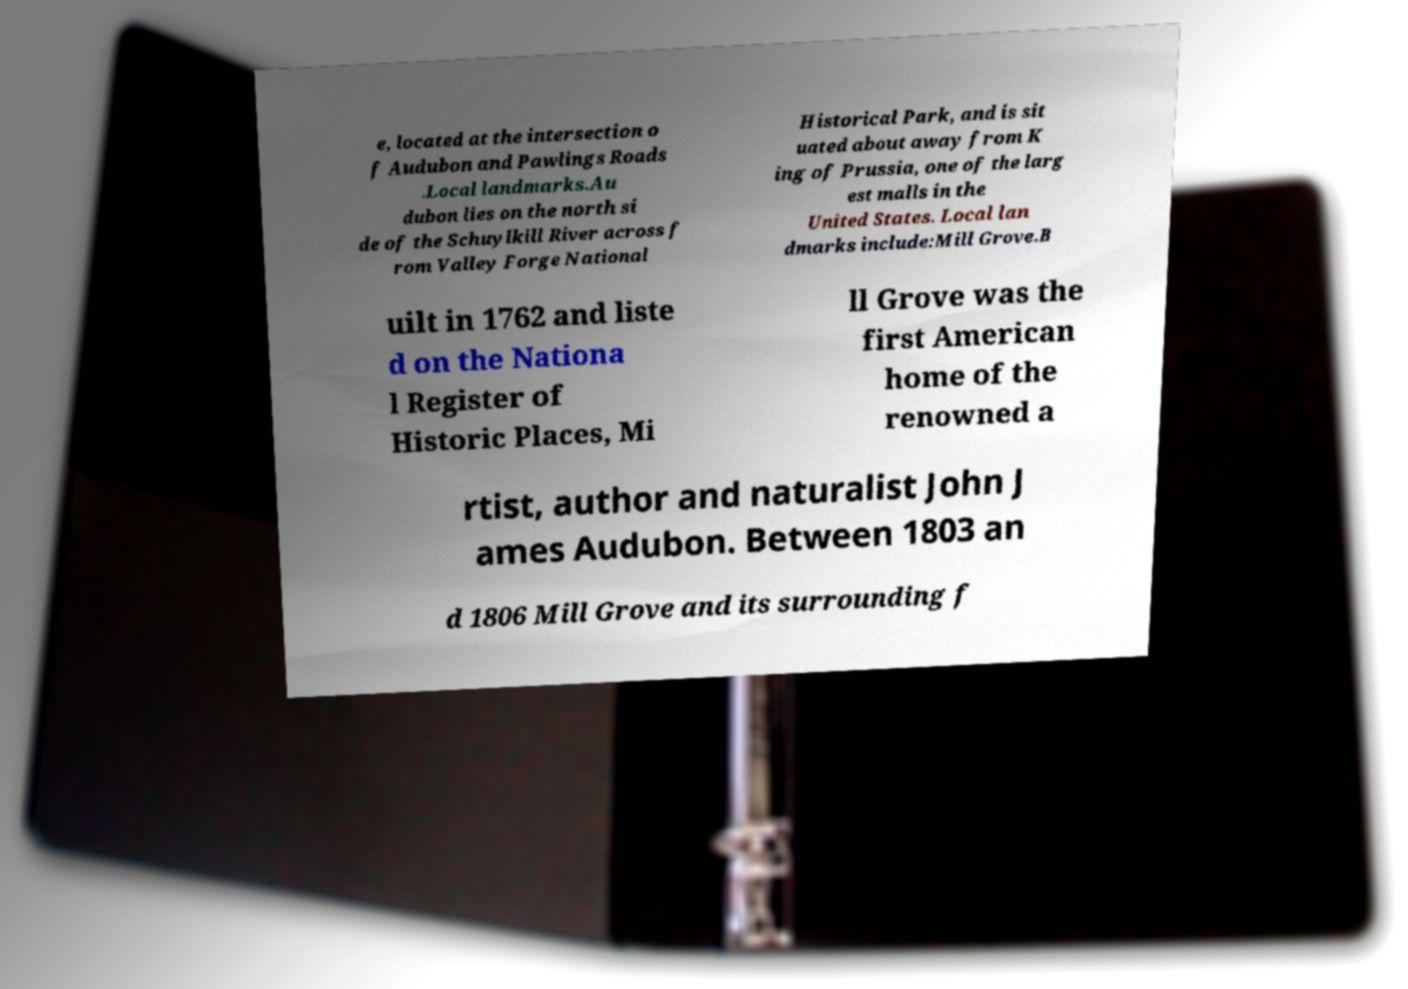Could you assist in decoding the text presented in this image and type it out clearly? e, located at the intersection o f Audubon and Pawlings Roads .Local landmarks.Au dubon lies on the north si de of the Schuylkill River across f rom Valley Forge National Historical Park, and is sit uated about away from K ing of Prussia, one of the larg est malls in the United States. Local lan dmarks include:Mill Grove.B uilt in 1762 and liste d on the Nationa l Register of Historic Places, Mi ll Grove was the first American home of the renowned a rtist, author and naturalist John J ames Audubon. Between 1803 an d 1806 Mill Grove and its surrounding f 